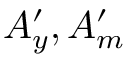Convert formula to latex. <formula><loc_0><loc_0><loc_500><loc_500>A _ { y } ^ { \prime } , A _ { m } ^ { \prime }</formula> 